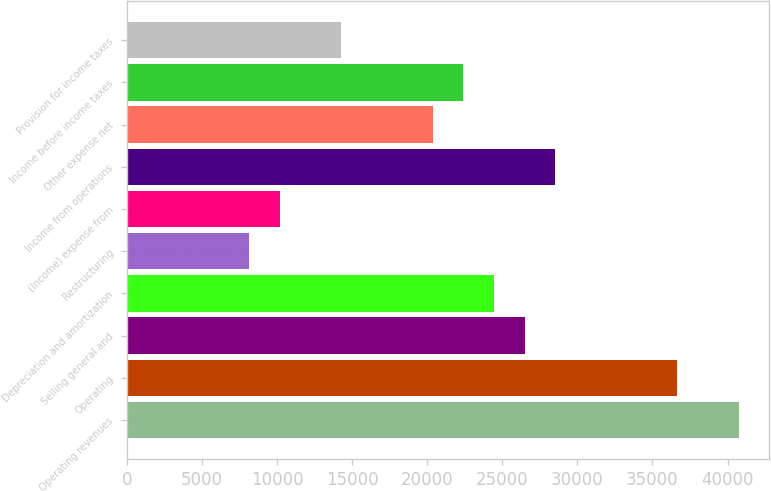Convert chart. <chart><loc_0><loc_0><loc_500><loc_500><bar_chart><fcel>Operating revenues<fcel>Operating<fcel>Selling general and<fcel>Depreciation and amortization<fcel>Restructuring<fcel>(Income) expense from<fcel>Income from operations<fcel>Other expense net<fcel>Income before income taxes<fcel>Provision for income taxes<nl><fcel>40733<fcel>36659.8<fcel>26476.8<fcel>24440.2<fcel>8147.4<fcel>10184<fcel>28513.4<fcel>20367<fcel>22403.6<fcel>14257.2<nl></chart> 